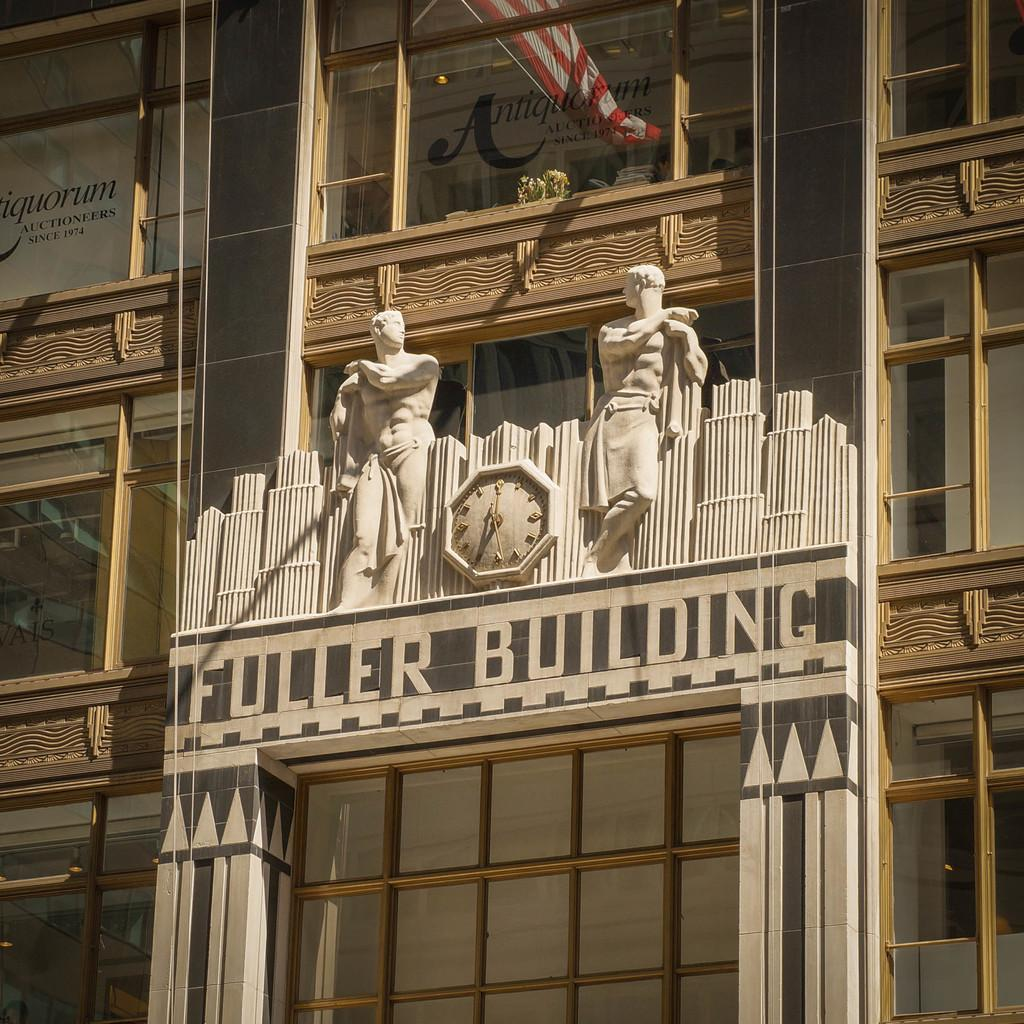What type of structure is present in the image? There is a building in the image. What feature can be seen on the building? The building has windows. What additional object is present in the image? There is a flag in the image. Can you describe another object in the image? There is a statue in the image. What time-related object is visible in the image? There is a clock in the image. How does the passenger interact with the clock in the image? There is no passenger present in the image, so there is no interaction with the clock. 